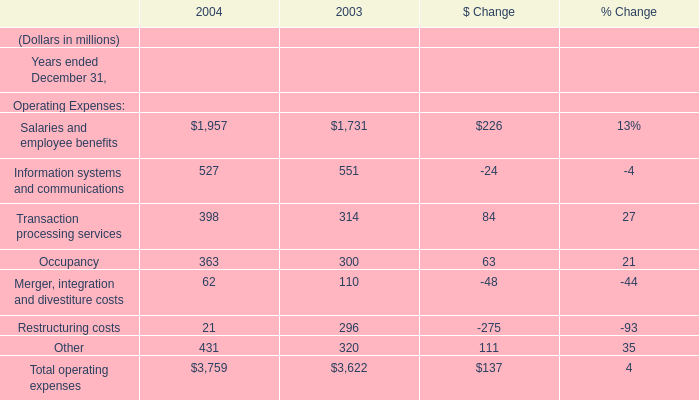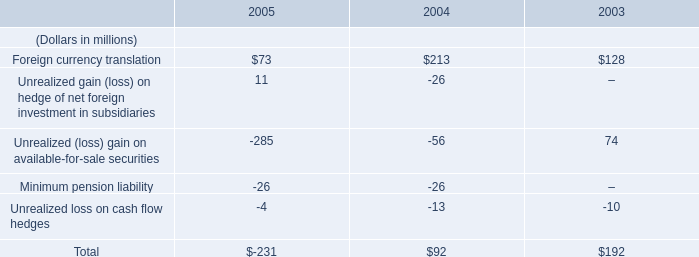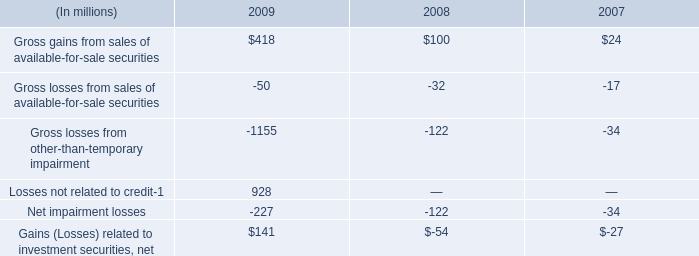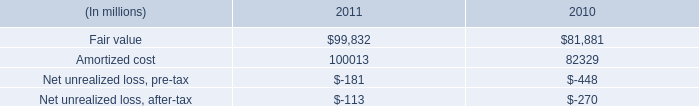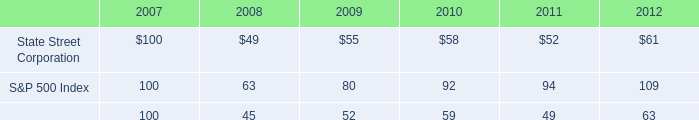what is the cumulative total shareholder return on state street's common stock in 2012 as a percentage of the average shareholder return on common stock in the s&p 500? 
Computations: (61 / 109)
Answer: 0.55963. 